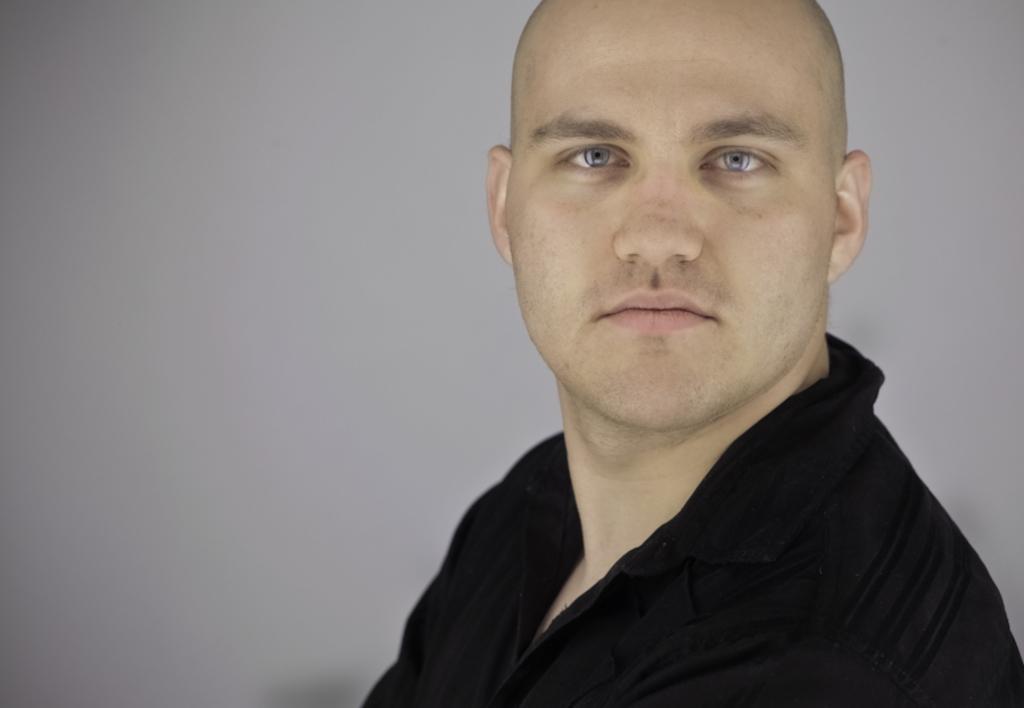In one or two sentences, can you explain what this image depicts? This image consists of a man wearing a black shirt. The background is gray in color. 